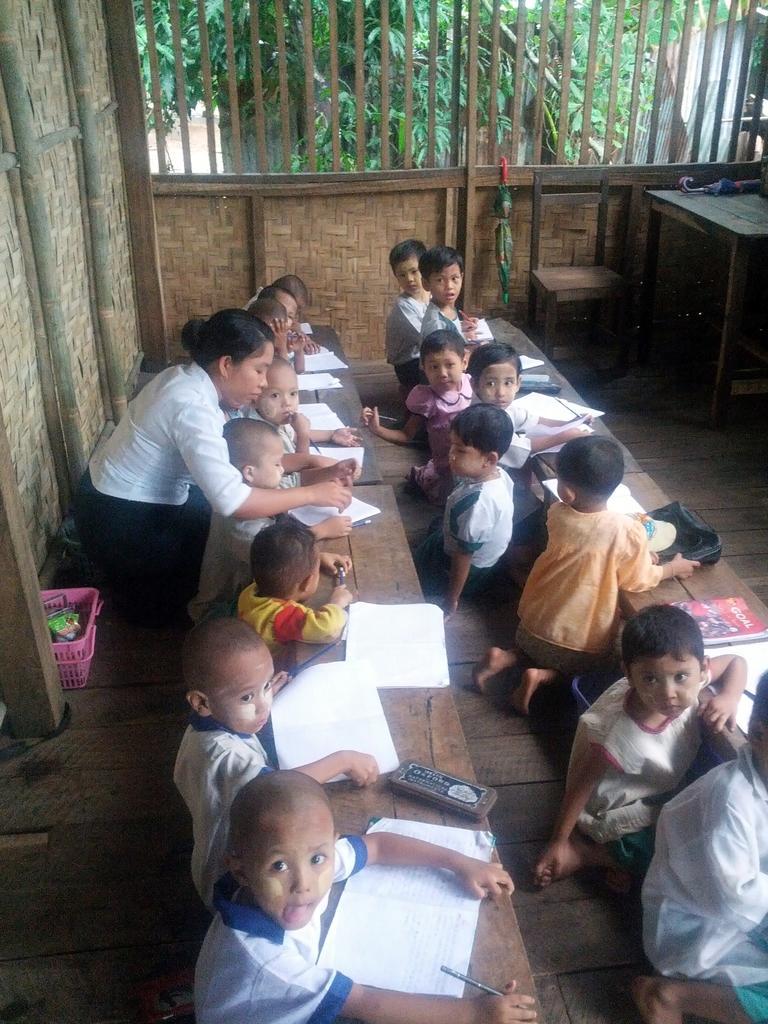Please provide a concise description of this image. In this image we can see a woman and some children sitting on the floor in a room and there are few tables with some books and other objects. We can see a chair and beside there is a table and on the table, there is an umbrella and we can see some other objects in the room. There are some trees in the background. 